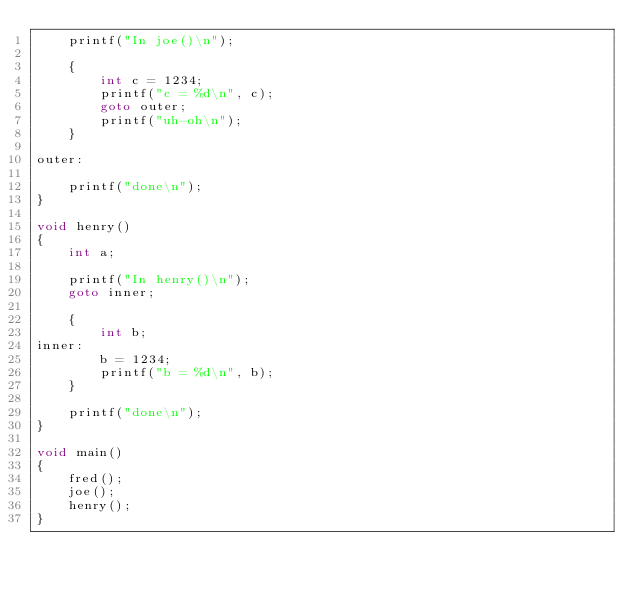<code> <loc_0><loc_0><loc_500><loc_500><_C_>    printf("In joe()\n");

    {
        int c = 1234;
        printf("c = %d\n", c);
        goto outer;
        printf("uh-oh\n");
    }

outer:

    printf("done\n");
}

void henry()
{
    int a;

    printf("In henry()\n");
    goto inner;

    {
        int b;
inner:
        b = 1234;
        printf("b = %d\n", b);
    }

    printf("done\n");
}

void main()
{
    fred();
    joe();
    henry();
}
</code> 